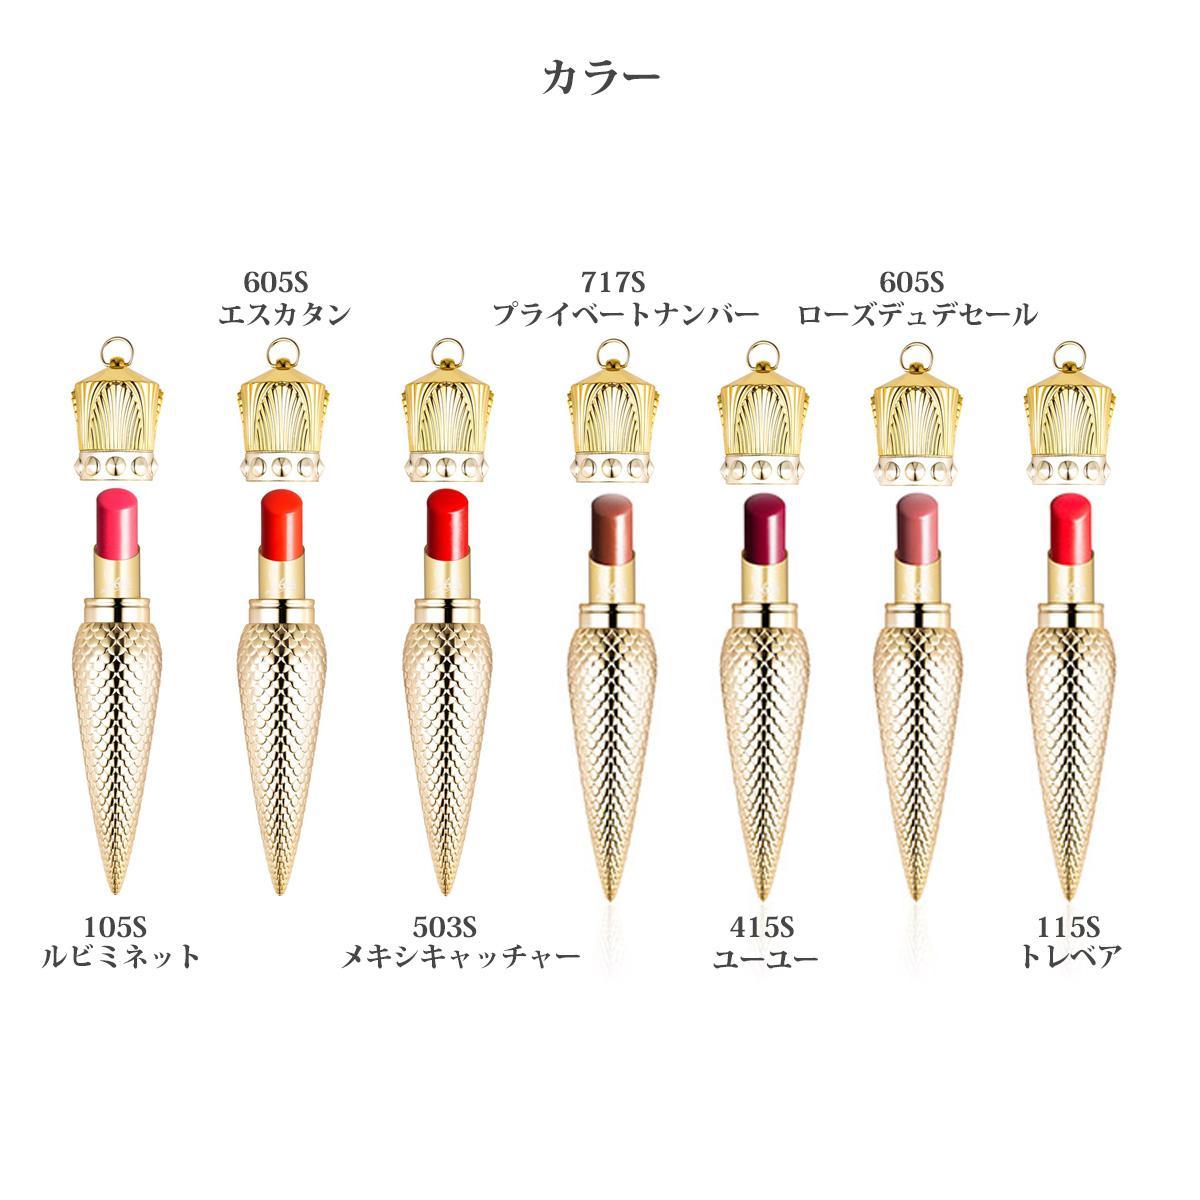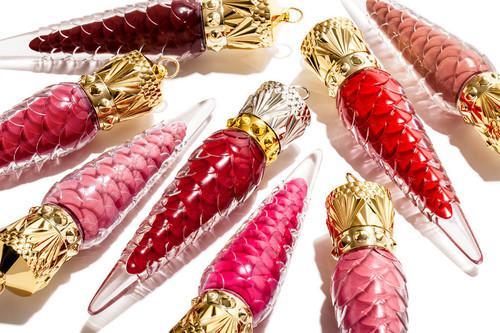The first image is the image on the left, the second image is the image on the right. Assess this claim about the two images: "An image shows eight different makeup shades in tapered decorative containers, displayed scattered instead of in rows.". Correct or not? Answer yes or no. Yes. The first image is the image on the left, the second image is the image on the right. Evaluate the accuracy of this statement regarding the images: "One vial of cone shaped lip gloss is shown in one of the images while more are shown in the other.". Is it true? Answer yes or no. No. 